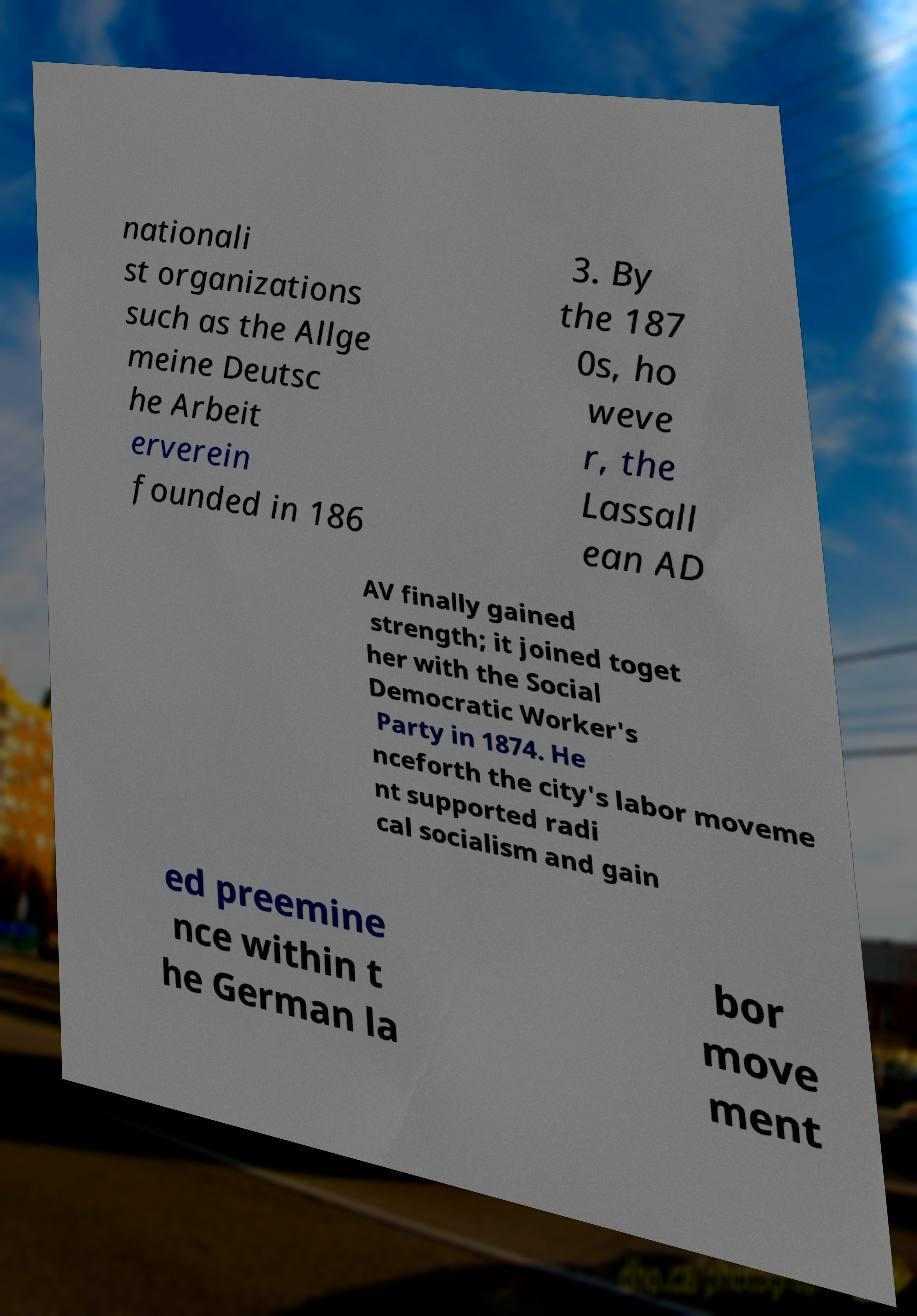Please read and relay the text visible in this image. What does it say? nationali st organizations such as the Allge meine Deutsc he Arbeit erverein founded in 186 3. By the 187 0s, ho weve r, the Lassall ean AD AV finally gained strength; it joined toget her with the Social Democratic Worker's Party in 1874. He nceforth the city's labor moveme nt supported radi cal socialism and gain ed preemine nce within t he German la bor move ment 